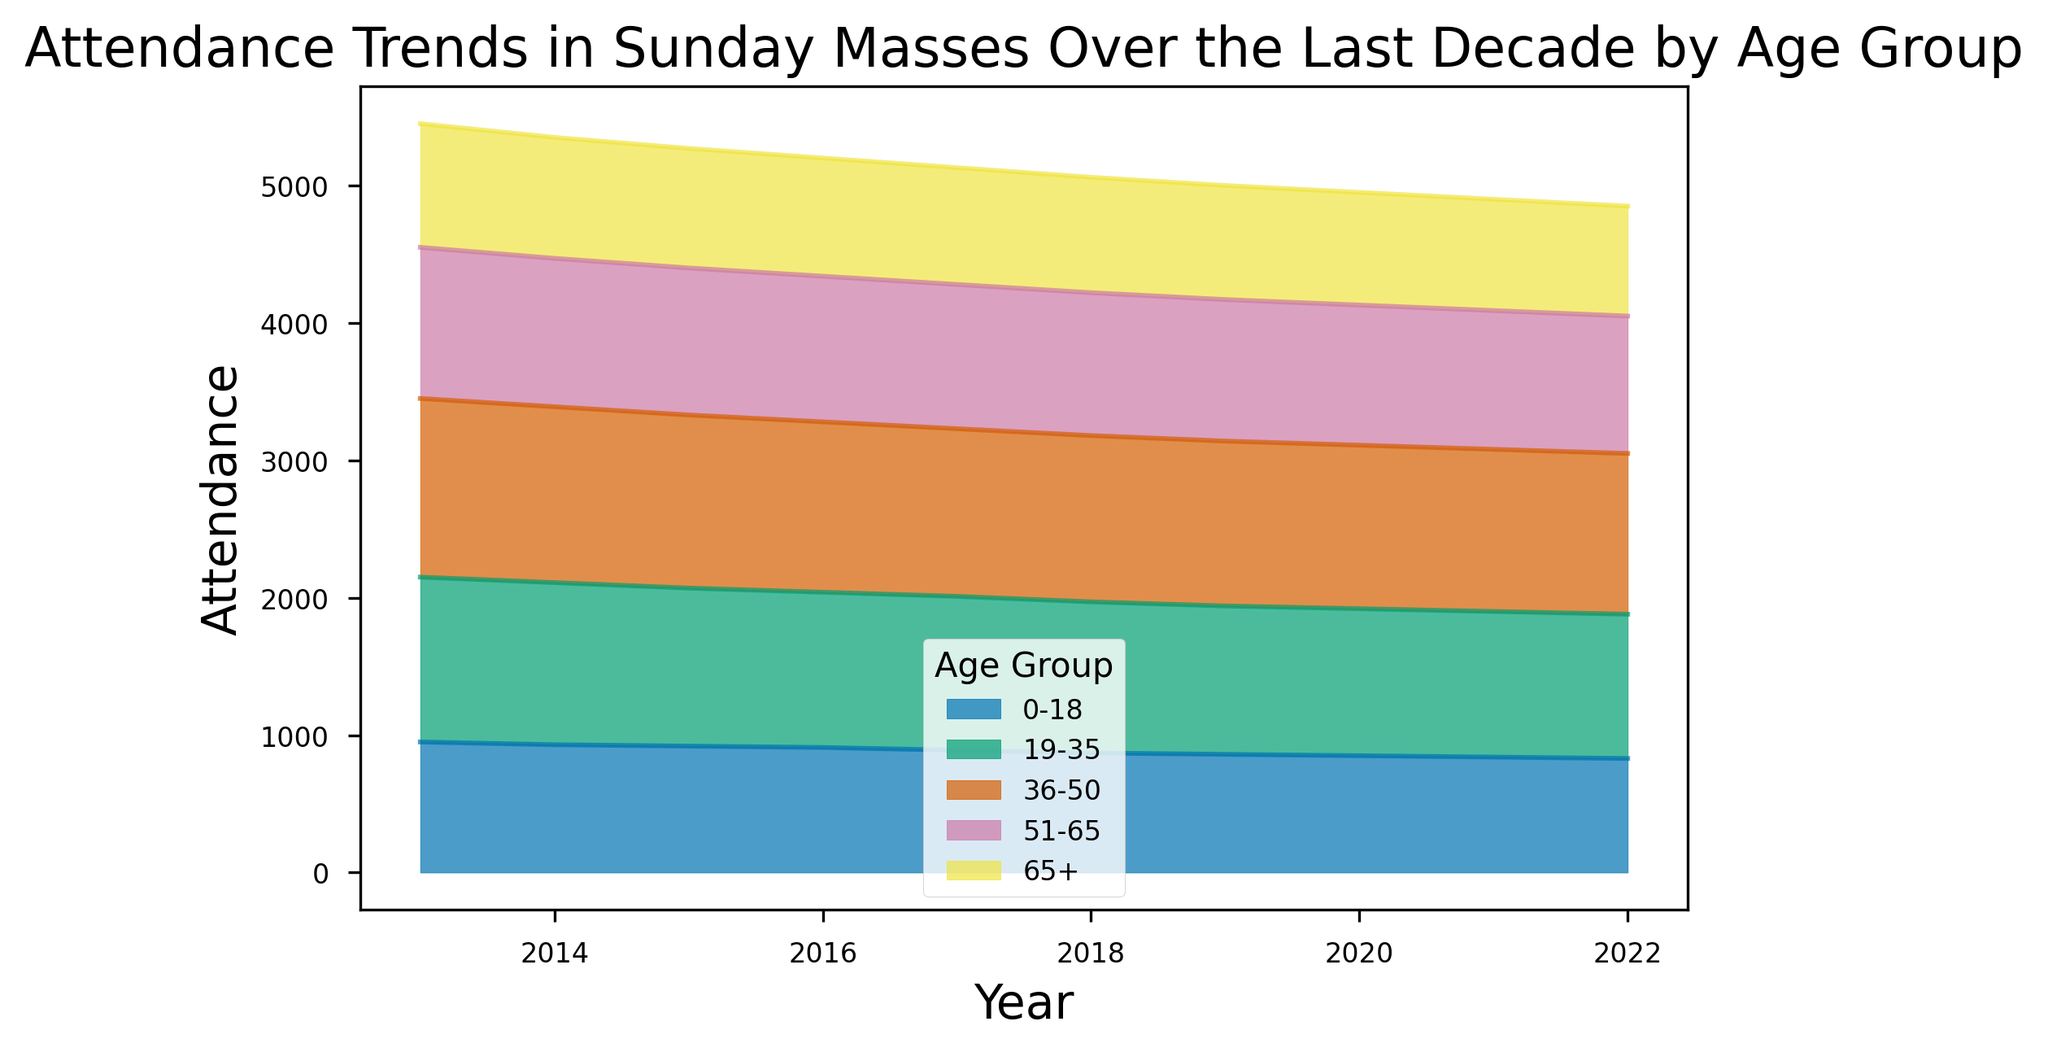What is the total attendance of the 19-35 age group over the decade? To find the total attendance for the 19-35 age group over the decade, sum the attendance numbers from 2013 to 2022: 1200 + 1180 + 1150 + 1130 + 1120 + 1100 + 1080 + 1070 + 1060 + 1050 = 10140.
Answer: 10140 Which age group had the highest attendance in 2016? To determine which age group had the highest attendance in 2016, inspect the data for that year. The attendances are: 0-18: 910, 19-35: 1130, 36-50: 1240, 51-65: 1060, 65+: 860. The highest attendance is in the 36-50 age group.
Answer: 36-50 How did the overall attendance trend for the 0-18 age group change over the decade? To understand the trend for the 0-18 age group, look for the changes in attendance from 2013 to 2022: 950, 930, 920, 910, 890, 870, 860, 850, 840, 830. The trend shows a steady decrease over the years.
Answer: Decrease What is the average attendance of the 51-65 age group in the years 2019 and 2020? Calculate the average attendance by summing the attendance of the 51-65 age group in 2019 and 2020, then divide by 2: (1030 + 1020) / 2 = 1025.
Answer: 1025 Which age group's attendance has decreased the most over the decade? To find the age group with the largest decrease, examine the attendance difference from 2013 to 2022 for each age group. Differences are: 0-18: 950 - 830 = 120, 19-35: 1200 - 1050 = 150, 36-50: 1300 - 1170 = 130, 51-65: 1100 - 1000 = 100, 65+: 900 - 800 = 100. The 19-35 age group shows the largest decrease.
Answer: 19-35 What is the attendance trend for the 65+ age group from 2017 to 2022? Look at the attendance values for the 65+ age group from 2017 to 2022: 850, 840, 830, 820, 810, 800. The trend indicates a steady decrease.
Answer: Decrease During which year did the 36-50 age group see the biggest drop in attendance? Compare the year-on-year differences in attendance in the 36-50 age group: 
2013-2014: 1300 - 1280 = 20 
2014-2015: 1280 - 1260 = 20 
2015-2016: 1260 - 1240 = 20 
2016-2017: 1240 - 1220 = 20 
2017-2018: 1220 - 1210 = 10 
2018-2019: 1210 - 1200 = 10 
2019-2020: 1200 - 1190 = 10 
2020-2021: 1190 - 1180 = 10 
2021-2022: 1180 - 1170 = 10
The year 2016 saw the most significant drop (20).
Answer: 2016 Compare the attendance of the 19-35 and 51-65 age groups in 2022. In 2022, the attendance for 19-35 was 1050 and for 51-65 was 1000. The 19-35 age group had a higher attendance by 50.
Answer: 19-35 